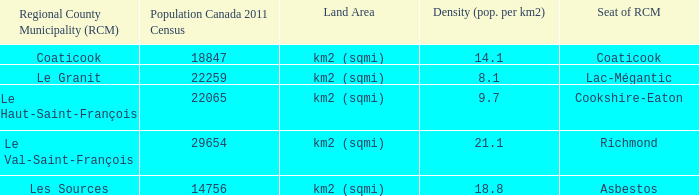What is the seat of the RCM in the county that has a density of 9.7? Cookshire-Eaton. 